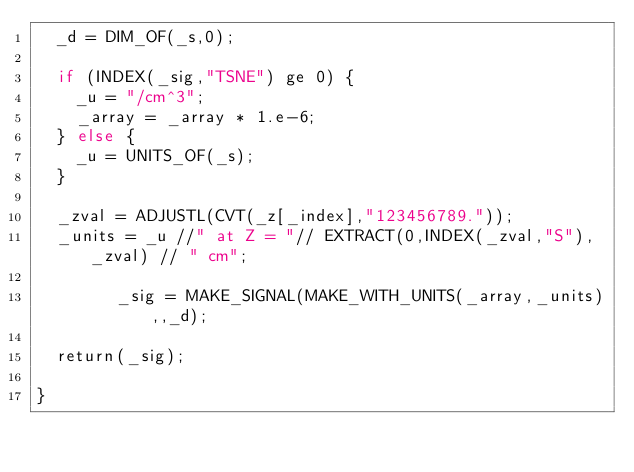Convert code to text. <code><loc_0><loc_0><loc_500><loc_500><_SML_>	_d = DIM_OF(_s,0);

	if (INDEX(_sig,"TSNE") ge 0) {
	  _u = "/cm^3";
	  _array = _array * 1.e-6;
	} else {
	  _u = UNITS_OF(_s);
	}

	_zval = ADJUSTL(CVT(_z[_index],"123456789."));
	_units = _u //" at Z = "// EXTRACT(0,INDEX(_zval,"S"),_zval) // " cm";

        _sig = MAKE_SIGNAL(MAKE_WITH_UNITS(_array,_units),,_d); 

	return(_sig);

}
		
	
</code> 